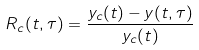<formula> <loc_0><loc_0><loc_500><loc_500>R _ { c } ( t , \tau ) = \frac { y _ { c } ( t ) - y ( t , \tau ) } { y _ { c } ( t ) }</formula> 